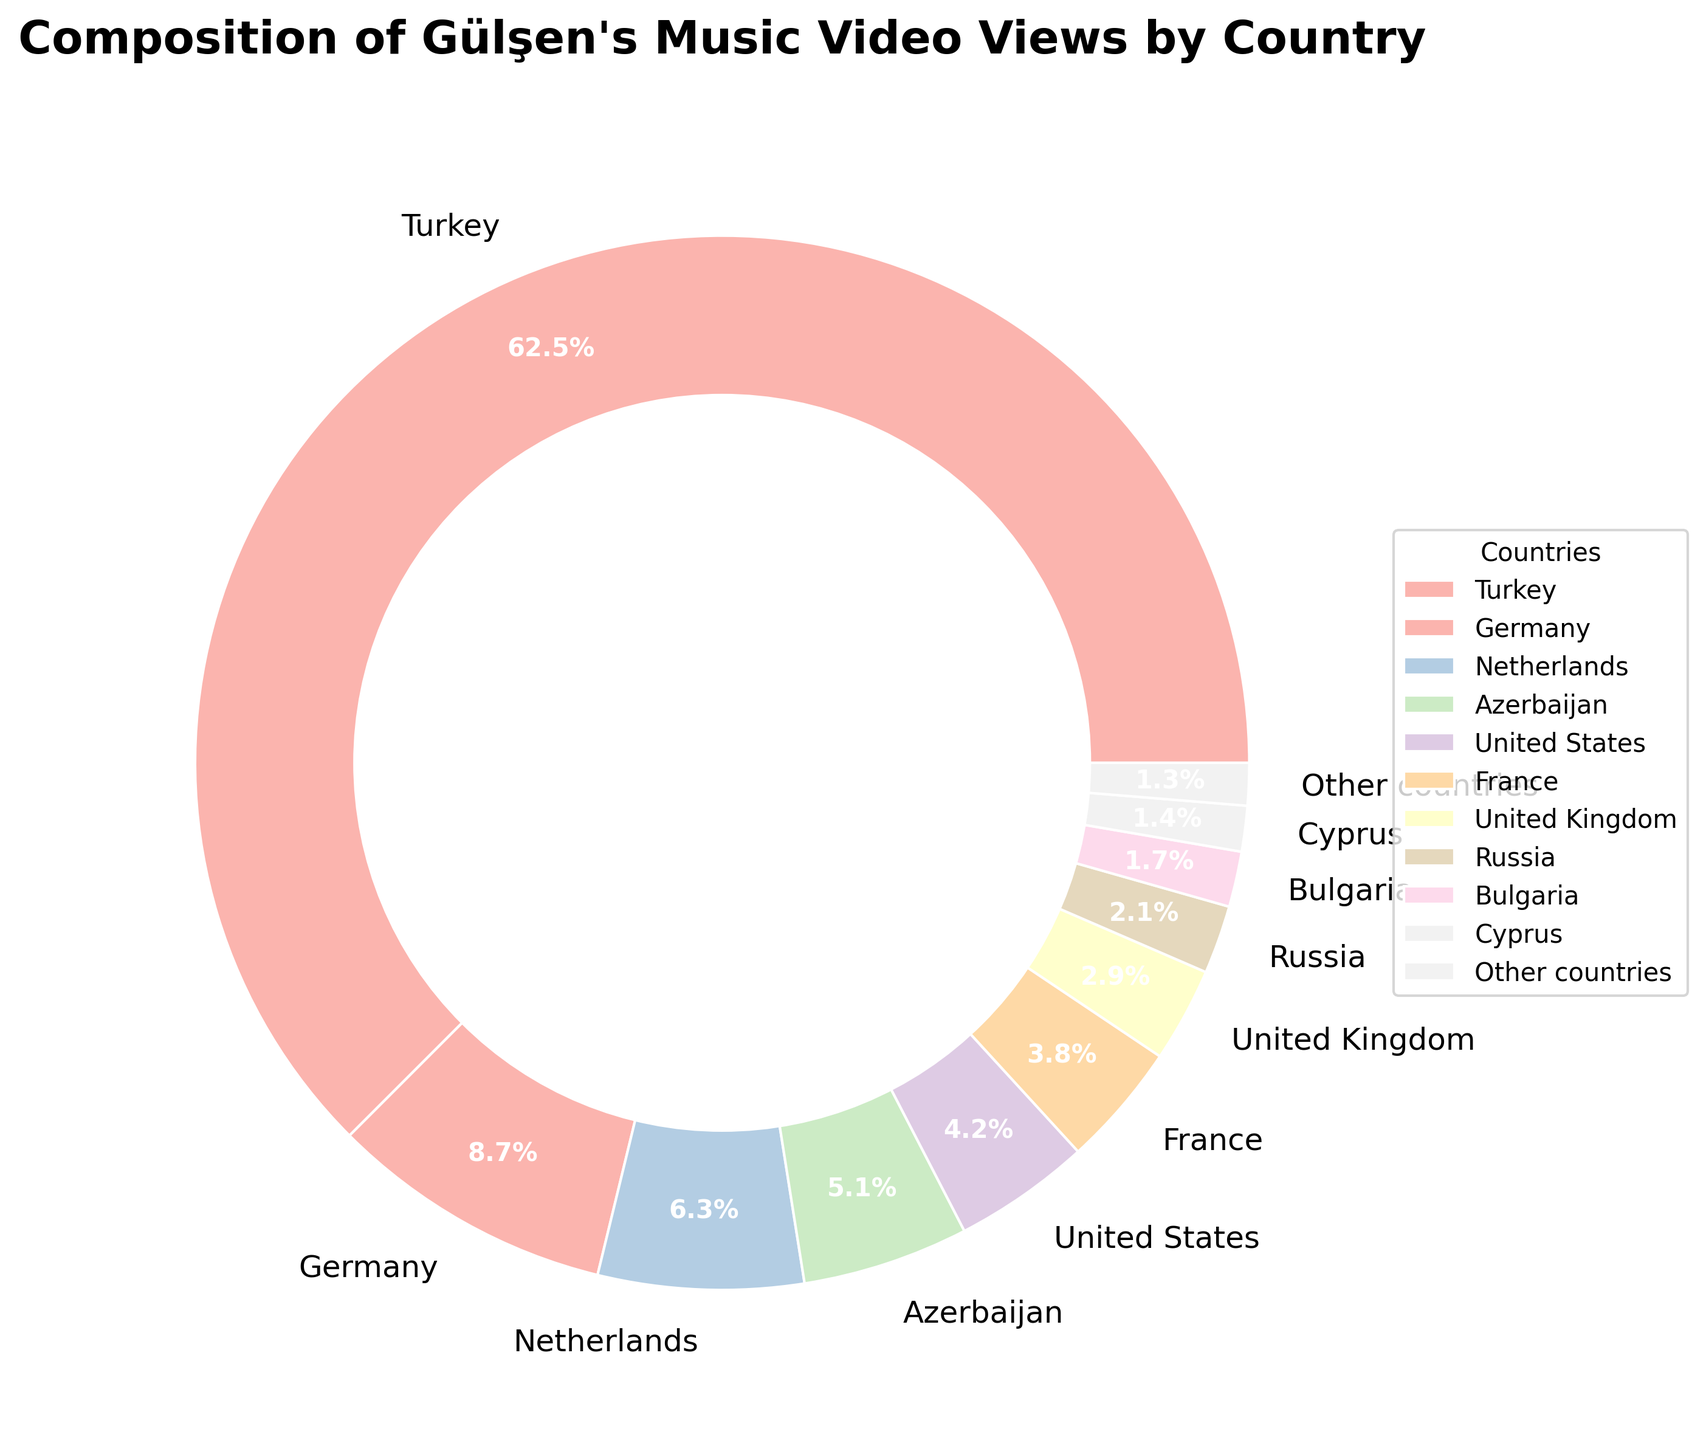What percentage of Gülşen's music video views come from Turkey? According to the pie chart, Turkey accounts for 62.5% of the total views. This can be directly read from the labeled segment of the pie chart indicating Turkey.
Answer: 62.5% Which country has the second highest percentage of views for Gülşen's music videos? By looking at the pie chart, Germany is labeled as having 8.7% of the views, which is the second highest percentage after Turkey.
Answer: Germany What is the combined percentage of views from the Netherlands, Azerbaijan, and the United States? Add the percentages for these three countries: Netherlands (6.3%), Azerbaijan (5.1%), and United States (4.2%). The sum is 6.3 + 5.1 + 4.2 = 15.6%.
Answer: 15.6% Does France have a higher percentage of views compared to the United Kingdom? From the pie chart, France has 3.8% of the views, whereas the United Kingdom has 2.9%. Since 3.8 is greater than 2.9, France has a higher percentage of views.
Answer: Yes What is the difference in percentage between the views from Russia and Bulgaria? Russia has 2.1% of views while Bulgaria has 1.7%. The difference is 2.1 - 1.7 = 0.4%.
Answer: 0.4% How do the combined percentages of Russia and Cyprus compare to the percentage of Germany? Russia (2.1%) and Cyprus (1.4%) together have 2.1 + 1.4 = 3.5%, while Germany alone has 8.7%. Since 3.5% is less than 8.7%, Germany has a higher percentage.
Answer: Germany has a higher percentage Which segment color represents the views from Turkey? According to the pie chart's color segments, the one representing Turkey is visually the largest and typically colored in a standout color compared to others.
Answer: Largest and standout color What is the average percentage of views from the United States, France, and United Kingdom? The percentages are United States (4.2%), France (3.8%), United Kingdom (2.9%). The sum is 4.2 + 3.8 + 2.9 = 10.9%. The average is 10.9 / 3 = 3.63%.
Answer: 3.63% Which countries contribute less than 5% of views but more than 2%? From the pie chart, the countries that fit this criterion are the United States (4.2%) and France (3.8%).
Answer: United States and France 